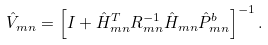Convert formula to latex. <formula><loc_0><loc_0><loc_500><loc_500>\hat { V } _ { m n } = \left [ I + \hat { H } _ { m n } ^ { T } R _ { m n } ^ { - 1 } \hat { H } _ { m n } \hat { P } _ { m n } ^ { b } \right ] ^ { - 1 } .</formula> 